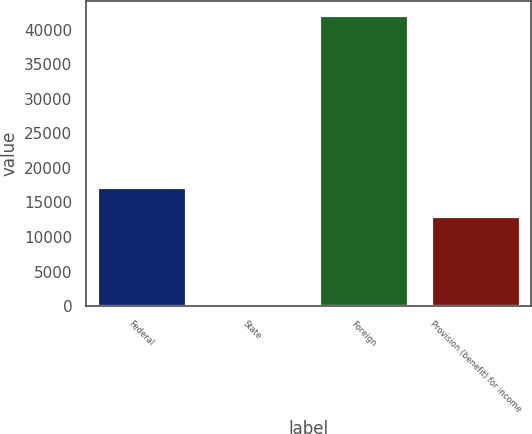Convert chart. <chart><loc_0><loc_0><loc_500><loc_500><bar_chart><fcel>Federal<fcel>State<fcel>Foreign<fcel>Provision (benefit) for income<nl><fcel>17198.6<fcel>279<fcel>42085<fcel>13018<nl></chart> 